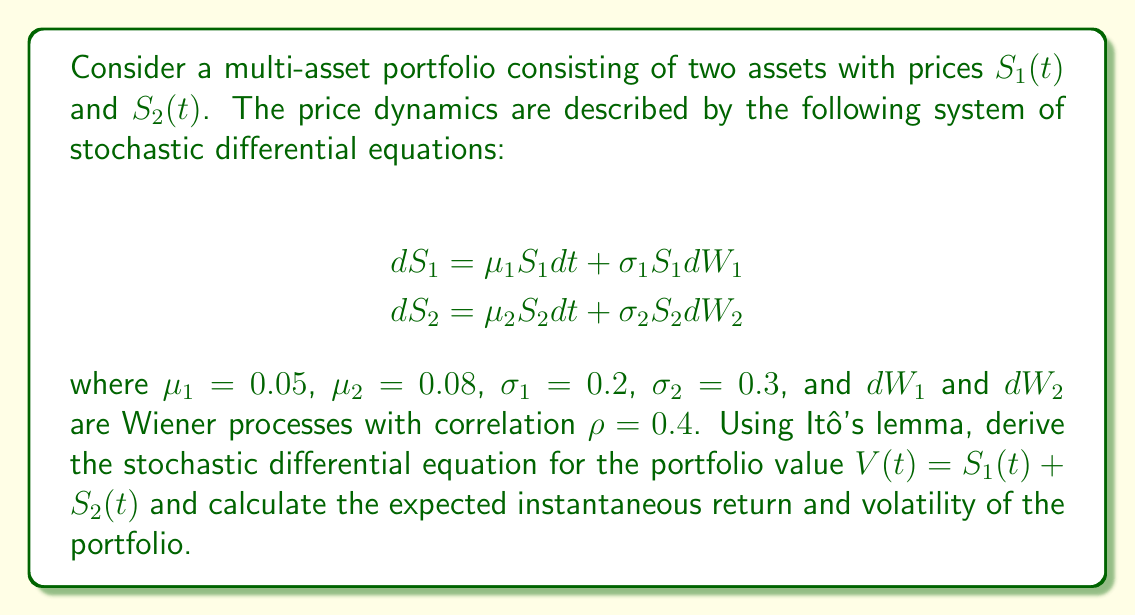Give your solution to this math problem. To solve this problem, we'll follow these steps:

1) Apply Itô's lemma to derive the SDE for $V(t)$:
   
   $$dV = \frac{\partial V}{\partial S_1} dS_1 + \frac{\partial V}{\partial S_2} dS_2 + \frac{1}{2} \frac{\partial^2 V}{\partial S_1^2} (dS_1)^2 + \frac{1}{2} \frac{\partial^2 V}{\partial S_2^2} (dS_2)^2 + \frac{\partial^2 V}{\partial S_1 \partial S_2} dS_1 dS_2$$

   Since $V = S_1 + S_2$, we have $\frac{\partial V}{\partial S_1} = \frac{\partial V}{\partial S_2} = 1$ and all second derivatives are zero.

2) Substitute the SDEs for $dS_1$ and $dS_2$:

   $$dV = (\mu_1 S_1 dt + \sigma_1 S_1 dW_1) + (\mu_2 S_2 dt + \sigma_2 S_2 dW_2)$$

3) Rearrange terms:

   $$dV = (\mu_1 S_1 + \mu_2 S_2) dt + \sigma_1 S_1 dW_1 + \sigma_2 S_2 dW_2$$

4) The expected instantaneous return of the portfolio is:

   $$\mu_V = \frac{\mu_1 S_1 + \mu_2 S_2}{V}$$

5) To calculate the portfolio volatility, we need to compute $(dV)^2$:

   $$(dV)^2 = \sigma_1^2 S_1^2 (dW_1)^2 + \sigma_2^2 S_2^2 (dW_2)^2 + 2\sigma_1 \sigma_2 S_1 S_2 dW_1 dW_2$$

   Using $E[(dW_i)^2] = dt$ and $E[dW_1 dW_2] = \rho dt$, we get:

   $$E[(dV)^2] = (\sigma_1^2 S_1^2 + \sigma_2^2 S_2^2 + 2\rho \sigma_1 \sigma_2 S_1 S_2) dt$$

6) The instantaneous volatility of the portfolio is:

   $$\sigma_V = \sqrt{\frac{\sigma_1^2 S_1^2 + \sigma_2^2 S_2^2 + 2\rho \sigma_1 \sigma_2 S_1 S_2}{V^2}}$$
Answer: $dV = (\mu_1 S_1 + \mu_2 S_2) dt + \sigma_1 S_1 dW_1 + \sigma_2 S_2 dW_2$; $\mu_V = \frac{\mu_1 S_1 + \mu_2 S_2}{V}$; $\sigma_V = \sqrt{\frac{\sigma_1^2 S_1^2 + \sigma_2^2 S_2^2 + 2\rho \sigma_1 \sigma_2 S_1 S_2}{V^2}}$ 